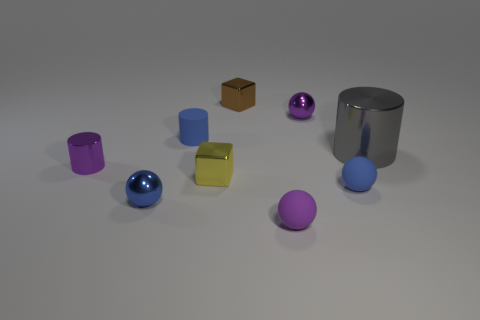Does the tiny purple rubber thing have the same shape as the small purple metal object on the left side of the blue shiny thing?
Offer a terse response. No. What number of things are metallic cylinders right of the yellow object or small rubber spheres in front of the small blue shiny ball?
Your answer should be very brief. 2. Are there fewer small purple metal cylinders on the left side of the large metal object than small yellow metallic things?
Offer a terse response. No. Are the blue cylinder and the tiny block that is on the left side of the brown metal cube made of the same material?
Your answer should be very brief. No. What is the blue cylinder made of?
Your answer should be very brief. Rubber. What is the material of the small block behind the tiny purple metallic thing that is on the left side of the small metallic cube that is behind the small yellow shiny thing?
Your response must be concise. Metal. Is the color of the large metallic cylinder the same as the small cube that is in front of the big gray shiny cylinder?
Keep it short and to the point. No. Are there any other things that have the same shape as the tiny yellow thing?
Your answer should be compact. Yes. There is a shiny thing on the right side of the small blue sphere that is to the right of the brown cube; what is its color?
Give a very brief answer. Gray. How many tiny brown matte cubes are there?
Your answer should be compact. 0. 